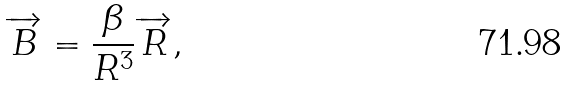Convert formula to latex. <formula><loc_0><loc_0><loc_500><loc_500>\overrightarrow { B } = \frac { \beta } { R ^ { 3 } } \overrightarrow { R } ,</formula> 